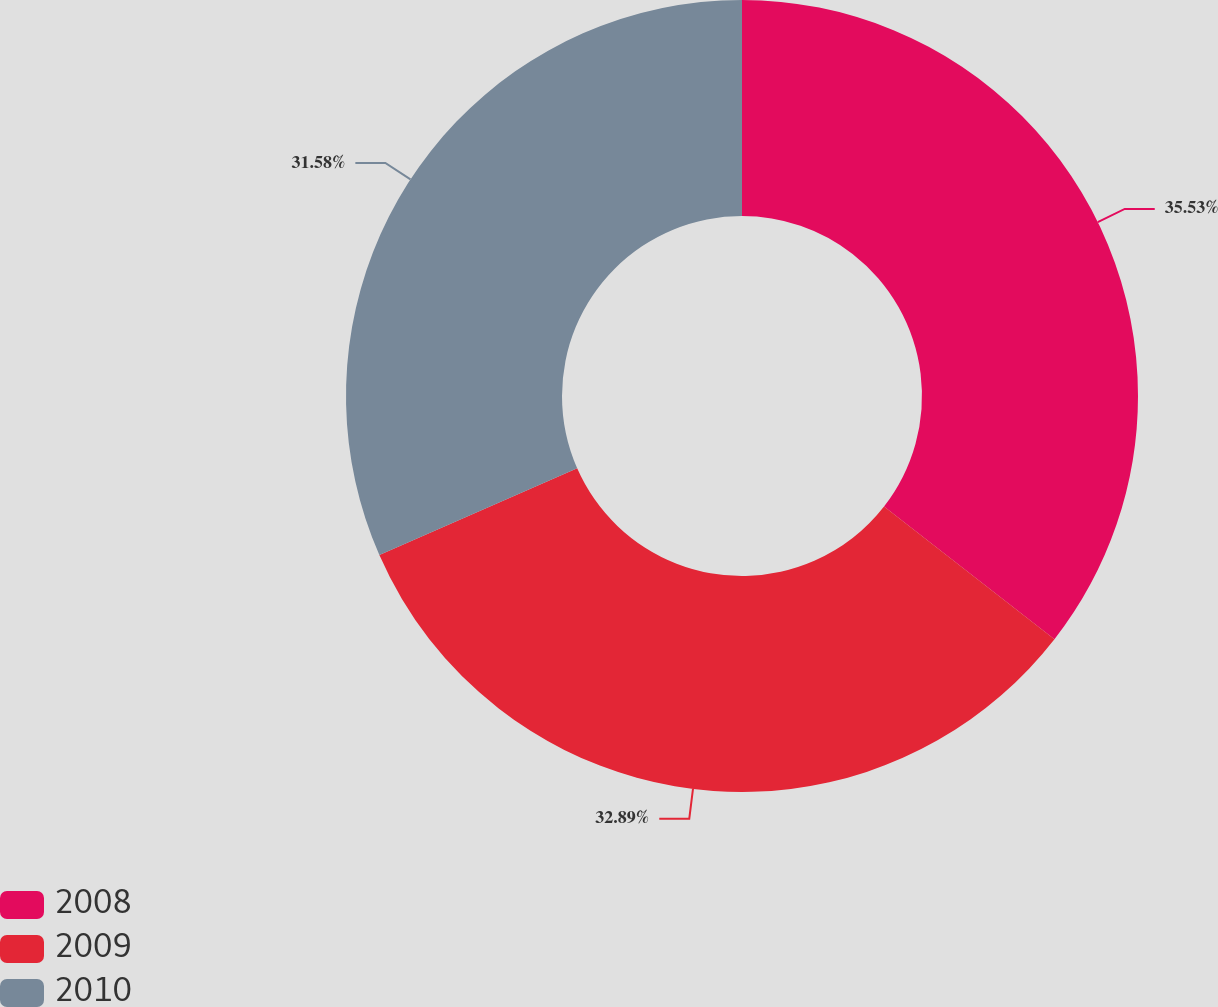<chart> <loc_0><loc_0><loc_500><loc_500><pie_chart><fcel>2008<fcel>2009<fcel>2010<nl><fcel>35.53%<fcel>32.89%<fcel>31.58%<nl></chart> 